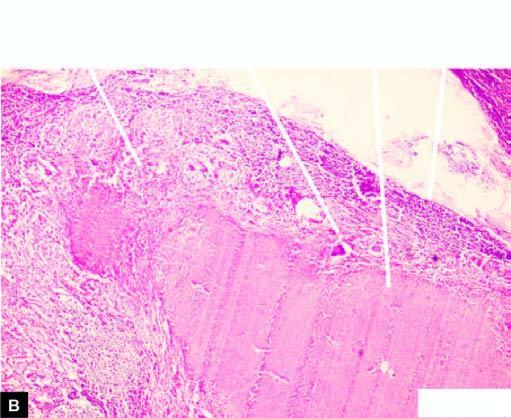what shows merging capsules and large areas of caseation necrosis?
Answer the question using a single word or phrase. Section of matted mass of lymph nodes 